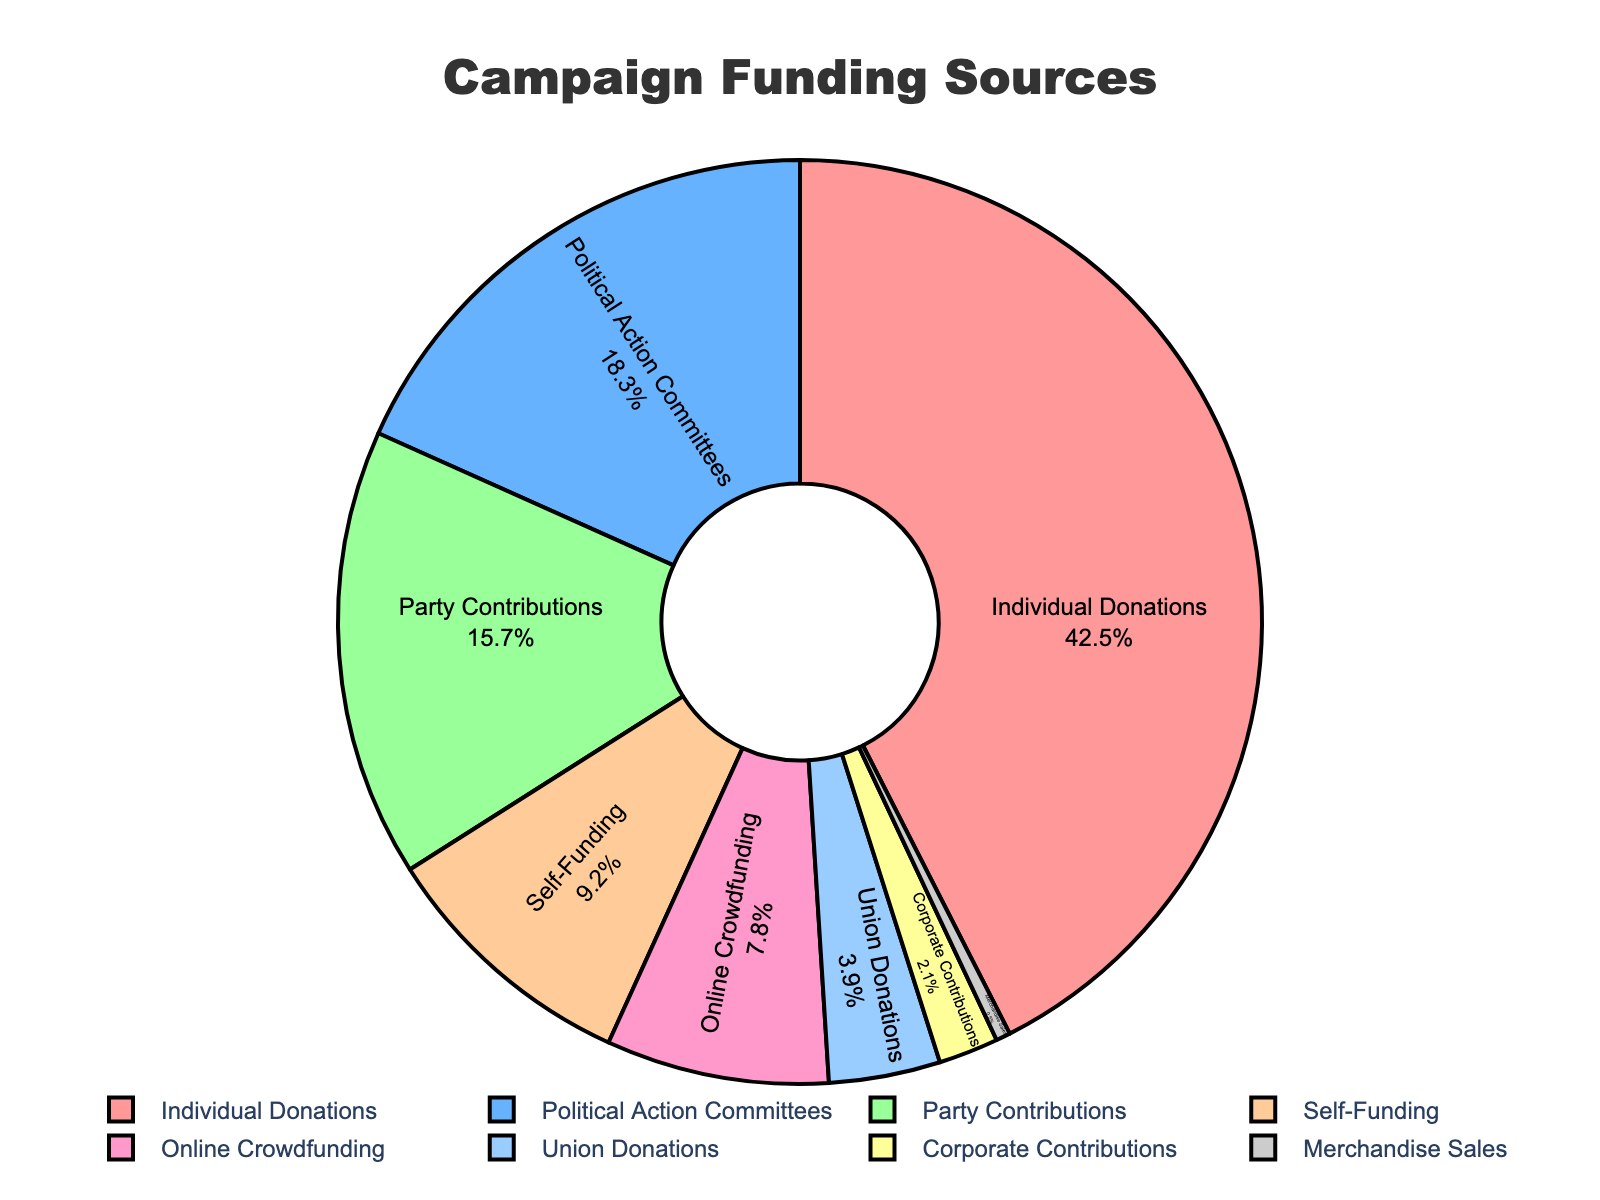What is the largest source of campaign funding? The largest source can be identified by looking at the funding source with the highest percentage. Individual Donations has 42.5%, which is higher than any other source.
Answer: Individual Donations Which funding source contributes the smallest percentage? The smallest contribution can be found by locating the funding source with the lowest percentage in the chart. Merchandise Sales has 0.5%, the smallest percentage among all sources.
Answer: Merchandise Sales How much more does Individual Donations contribute compared to Political Action Committees? First, identify the percentages for Individual Donations (42.5%) and Political Action Committees (18.3%). Then, subtract the smaller from the larger value: 42.5% - 18.3% = 24.2%.
Answer: 24.2% What is the combined percentage of Party Contributions and Union Donations? Locate the percentages for Party Contributions (15.7%) and Union Donations (3.9%) and add them together: 15.7% + 3.9% = 19.6%.
Answer: 19.6% Which sources contribute more than 15%? Determine which funding sources have percentages higher than 15%. These sources are Individual Donations (42.5%), Political Action Committees (18.3%), and Party Contributions (15.7%).
Answer: Individual Donations, Political Action Committees, and Party Contributions Is the percentage of Online Crowdfunding greater or less than the percentage of Self-Funding? Compare the percentages of Online Crowdfunding (7.8%) and Self-Funding (9.2%) to see which is larger. Online Crowdfunding is less than Self-Funding.
Answer: Less If you combine Corporate Contributions and Merchandise Sales, does the combined percentage exceed Union Donations? Combine the percentages for Corporate Contributions (2.1%) and Merchandise Sales (0.5%) to get 2.6%. Compare this to Union Donations, which is 3.9%. The combined percentage does not exceed Union Donations.
Answer: No What are the funding sources that contribute less than 10% each? Identify the sources with percentages less than 10%. These are Self-Funding (9.2%), Online Crowdfunding (7.8%), Union Donations (3.9%), Corporate Contributions (2.1%), and Merchandise Sales (0.5%).
Answer: Self-Funding, Online Crowdfunding, Union Donations, Corporate Contributions, Merchandise Sales How does the contribution from Political Action Committees compare to the contribution from Party Contributions? Compare the percentages of Political Action Committees (18.3%) and Party Contributions (15.7%). Political Action Committees contribute more than Party Contributions.
Answer: More What is the visual attribute of the largest segment in the pie chart? Identify the segment with the highest percentage, which is Individual Donations (42.5%). The largest segment is visually distinguished by the color associated with it, which is likely a specific shade in the chart.
Answer: Red 